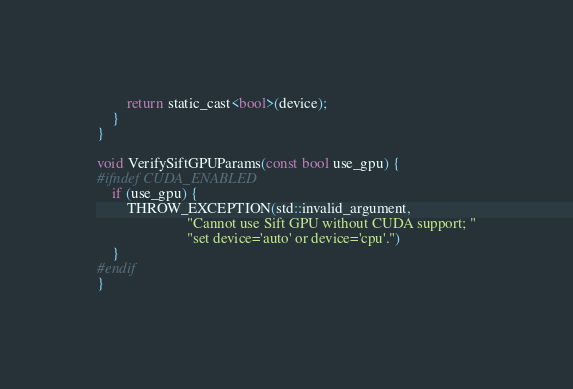Convert code to text. <code><loc_0><loc_0><loc_500><loc_500><_C_>        return static_cast<bool>(device);
    }
}

void VerifySiftGPUParams(const bool use_gpu) {
#ifndef CUDA_ENABLED
    if (use_gpu) {
        THROW_EXCEPTION(std::invalid_argument,
                        "Cannot use Sift GPU without CUDA support; "
                        "set device='auto' or device='cpu'.")
    }
#endif
}</code> 